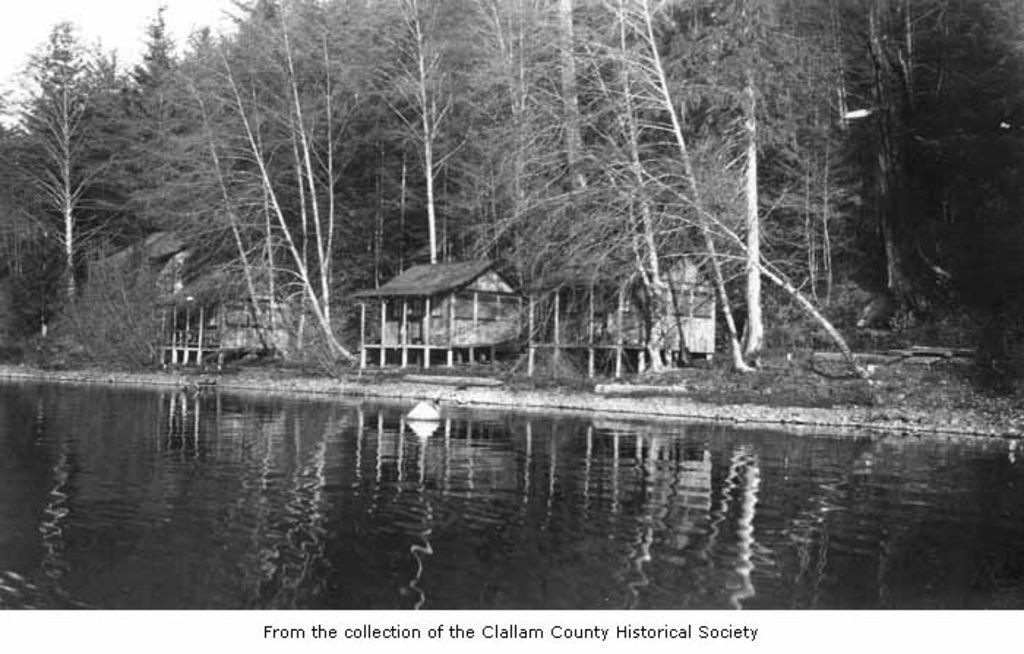What is visible in the image? Water is visible in the image. What can be seen in the background of the image? There are houses, trees, and the sky visible in the background of the image. What is the color scheme of the image? The image is in black and white. What type of jam is being spread on the base in the image? There is no jam or base present in the image; it features water, houses, trees, and the sky in black and white. 